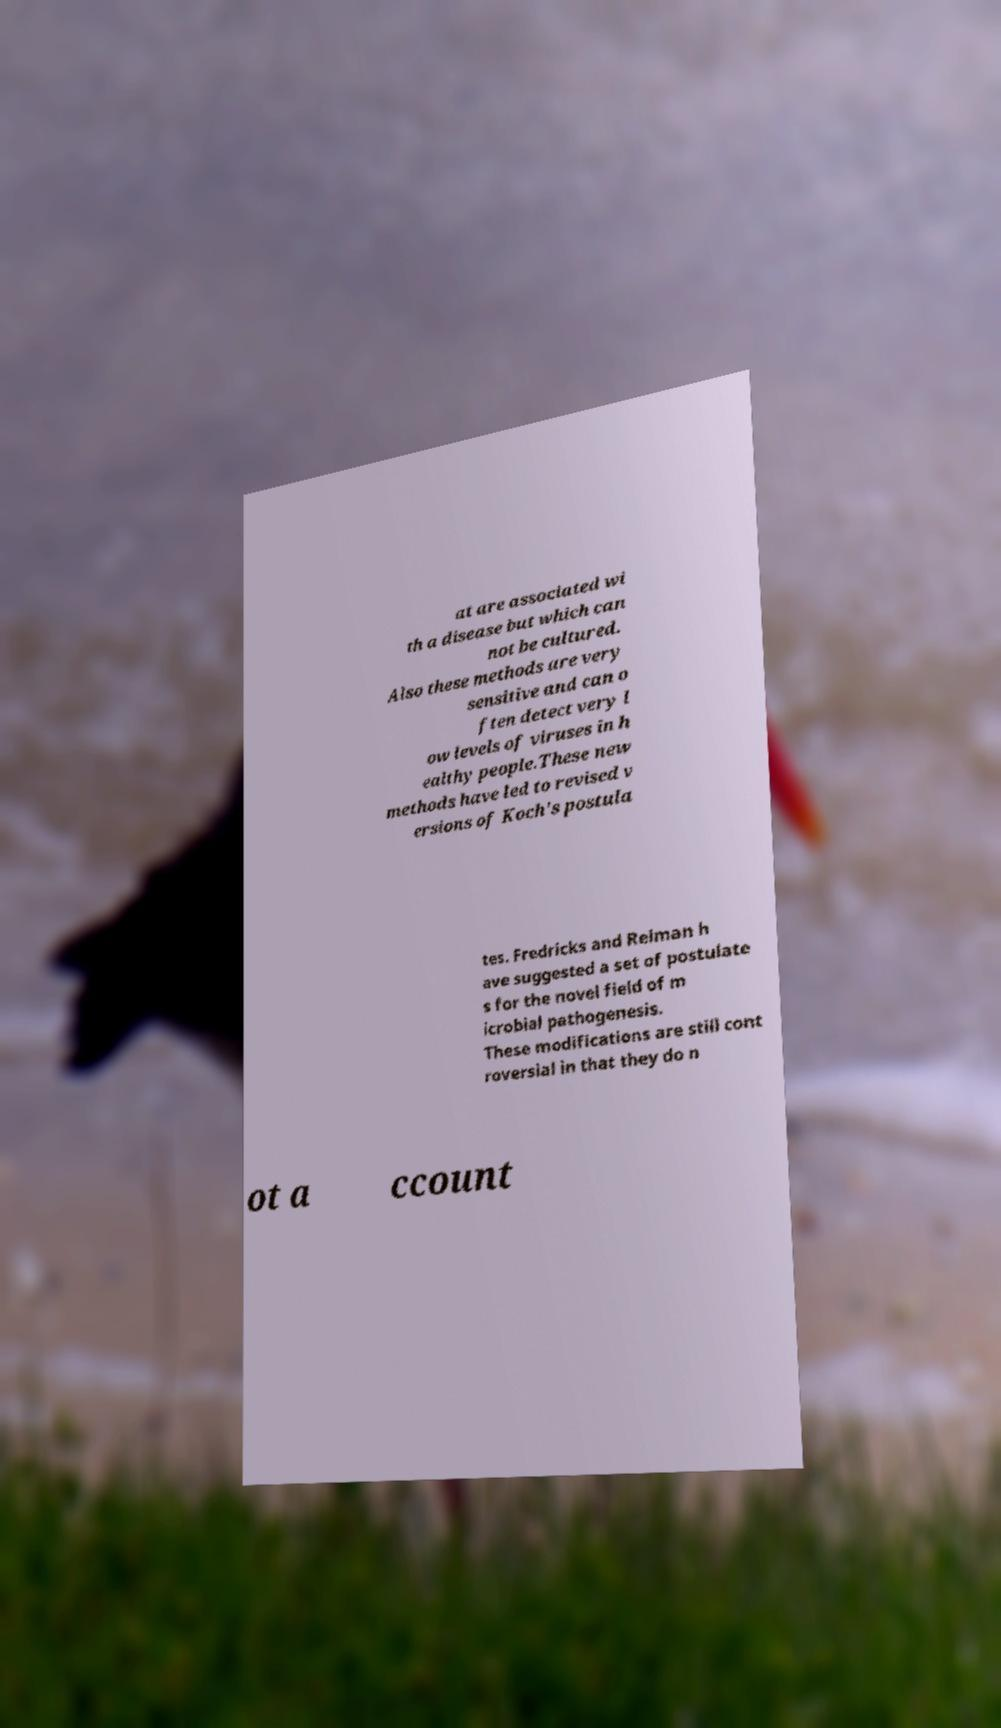There's text embedded in this image that I need extracted. Can you transcribe it verbatim? at are associated wi th a disease but which can not be cultured. Also these methods are very sensitive and can o ften detect very l ow levels of viruses in h ealthy people.These new methods have led to revised v ersions of Koch's postula tes. Fredricks and Relman h ave suggested a set of postulate s for the novel field of m icrobial pathogenesis. These modifications are still cont roversial in that they do n ot a ccount 